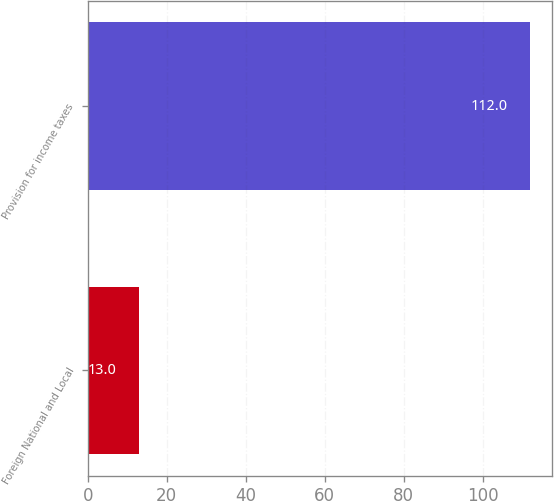Convert chart. <chart><loc_0><loc_0><loc_500><loc_500><bar_chart><fcel>Foreign National and Local<fcel>Provision for income taxes<nl><fcel>13<fcel>112<nl></chart> 